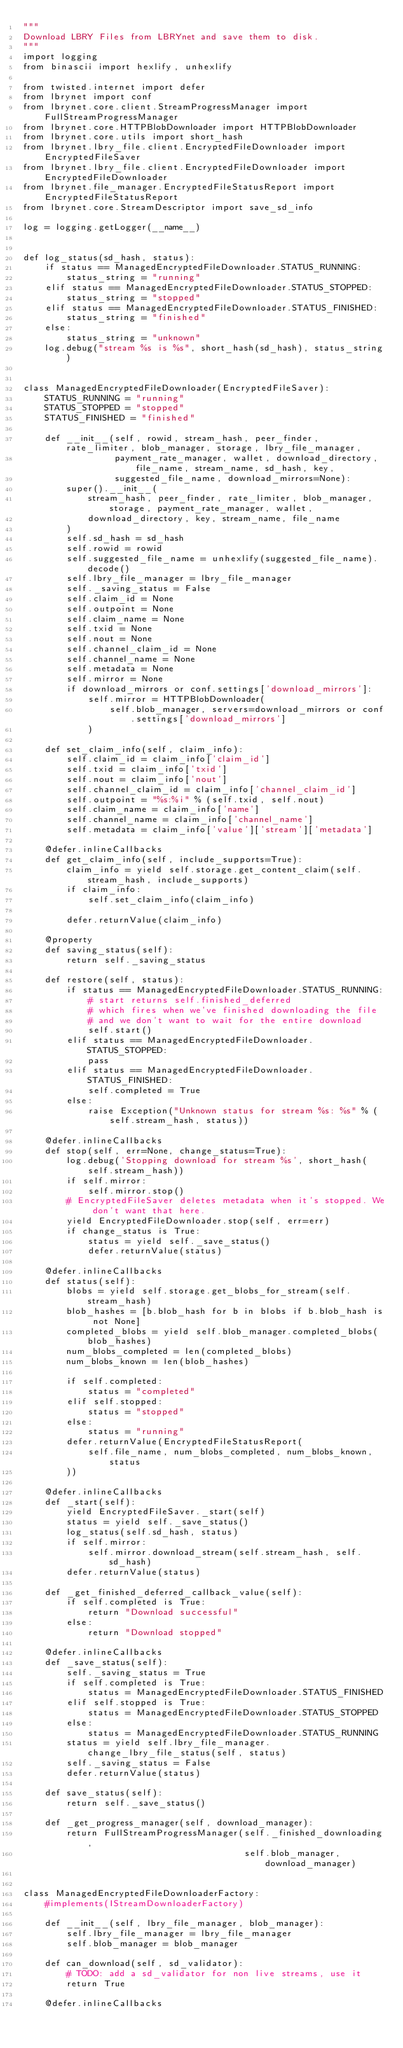Convert code to text. <code><loc_0><loc_0><loc_500><loc_500><_Python_>"""
Download LBRY Files from LBRYnet and save them to disk.
"""
import logging
from binascii import hexlify, unhexlify

from twisted.internet import defer
from lbrynet import conf
from lbrynet.core.client.StreamProgressManager import FullStreamProgressManager
from lbrynet.core.HTTPBlobDownloader import HTTPBlobDownloader
from lbrynet.core.utils import short_hash
from lbrynet.lbry_file.client.EncryptedFileDownloader import EncryptedFileSaver
from lbrynet.lbry_file.client.EncryptedFileDownloader import EncryptedFileDownloader
from lbrynet.file_manager.EncryptedFileStatusReport import EncryptedFileStatusReport
from lbrynet.core.StreamDescriptor import save_sd_info

log = logging.getLogger(__name__)


def log_status(sd_hash, status):
    if status == ManagedEncryptedFileDownloader.STATUS_RUNNING:
        status_string = "running"
    elif status == ManagedEncryptedFileDownloader.STATUS_STOPPED:
        status_string = "stopped"
    elif status == ManagedEncryptedFileDownloader.STATUS_FINISHED:
        status_string = "finished"
    else:
        status_string = "unknown"
    log.debug("stream %s is %s", short_hash(sd_hash), status_string)


class ManagedEncryptedFileDownloader(EncryptedFileSaver):
    STATUS_RUNNING = "running"
    STATUS_STOPPED = "stopped"
    STATUS_FINISHED = "finished"

    def __init__(self, rowid, stream_hash, peer_finder, rate_limiter, blob_manager, storage, lbry_file_manager,
                 payment_rate_manager, wallet, download_directory, file_name, stream_name, sd_hash, key,
                 suggested_file_name, download_mirrors=None):
        super().__init__(
            stream_hash, peer_finder, rate_limiter, blob_manager, storage, payment_rate_manager, wallet,
            download_directory, key, stream_name, file_name
        )
        self.sd_hash = sd_hash
        self.rowid = rowid
        self.suggested_file_name = unhexlify(suggested_file_name).decode()
        self.lbry_file_manager = lbry_file_manager
        self._saving_status = False
        self.claim_id = None
        self.outpoint = None
        self.claim_name = None
        self.txid = None
        self.nout = None
        self.channel_claim_id = None
        self.channel_name = None
        self.metadata = None
        self.mirror = None
        if download_mirrors or conf.settings['download_mirrors']:
            self.mirror = HTTPBlobDownloader(
                self.blob_manager, servers=download_mirrors or conf.settings['download_mirrors']
            )

    def set_claim_info(self, claim_info):
        self.claim_id = claim_info['claim_id']
        self.txid = claim_info['txid']
        self.nout = claim_info['nout']
        self.channel_claim_id = claim_info['channel_claim_id']
        self.outpoint = "%s:%i" % (self.txid, self.nout)
        self.claim_name = claim_info['name']
        self.channel_name = claim_info['channel_name']
        self.metadata = claim_info['value']['stream']['metadata']

    @defer.inlineCallbacks
    def get_claim_info(self, include_supports=True):
        claim_info = yield self.storage.get_content_claim(self.stream_hash, include_supports)
        if claim_info:
            self.set_claim_info(claim_info)

        defer.returnValue(claim_info)

    @property
    def saving_status(self):
        return self._saving_status

    def restore(self, status):
        if status == ManagedEncryptedFileDownloader.STATUS_RUNNING:
            # start returns self.finished_deferred
            # which fires when we've finished downloading the file
            # and we don't want to wait for the entire download
            self.start()
        elif status == ManagedEncryptedFileDownloader.STATUS_STOPPED:
            pass
        elif status == ManagedEncryptedFileDownloader.STATUS_FINISHED:
            self.completed = True
        else:
            raise Exception("Unknown status for stream %s: %s" % (self.stream_hash, status))

    @defer.inlineCallbacks
    def stop(self, err=None, change_status=True):
        log.debug('Stopping download for stream %s', short_hash(self.stream_hash))
        if self.mirror:
            self.mirror.stop()
        # EncryptedFileSaver deletes metadata when it's stopped. We don't want that here.
        yield EncryptedFileDownloader.stop(self, err=err)
        if change_status is True:
            status = yield self._save_status()
            defer.returnValue(status)

    @defer.inlineCallbacks
    def status(self):
        blobs = yield self.storage.get_blobs_for_stream(self.stream_hash)
        blob_hashes = [b.blob_hash for b in blobs if b.blob_hash is not None]
        completed_blobs = yield self.blob_manager.completed_blobs(blob_hashes)
        num_blobs_completed = len(completed_blobs)
        num_blobs_known = len(blob_hashes)

        if self.completed:
            status = "completed"
        elif self.stopped:
            status = "stopped"
        else:
            status = "running"
        defer.returnValue(EncryptedFileStatusReport(
            self.file_name, num_blobs_completed, num_blobs_known, status
        ))

    @defer.inlineCallbacks
    def _start(self):
        yield EncryptedFileSaver._start(self)
        status = yield self._save_status()
        log_status(self.sd_hash, status)
        if self.mirror:
            self.mirror.download_stream(self.stream_hash, self.sd_hash)
        defer.returnValue(status)

    def _get_finished_deferred_callback_value(self):
        if self.completed is True:
            return "Download successful"
        else:
            return "Download stopped"

    @defer.inlineCallbacks
    def _save_status(self):
        self._saving_status = True
        if self.completed is True:
            status = ManagedEncryptedFileDownloader.STATUS_FINISHED
        elif self.stopped is True:
            status = ManagedEncryptedFileDownloader.STATUS_STOPPED
        else:
            status = ManagedEncryptedFileDownloader.STATUS_RUNNING
        status = yield self.lbry_file_manager.change_lbry_file_status(self, status)
        self._saving_status = False
        defer.returnValue(status)

    def save_status(self):
        return self._save_status()

    def _get_progress_manager(self, download_manager):
        return FullStreamProgressManager(self._finished_downloading,
                                         self.blob_manager, download_manager)


class ManagedEncryptedFileDownloaderFactory:
    #implements(IStreamDownloaderFactory)

    def __init__(self, lbry_file_manager, blob_manager):
        self.lbry_file_manager = lbry_file_manager
        self.blob_manager = blob_manager

    def can_download(self, sd_validator):
        # TODO: add a sd_validator for non live streams, use it
        return True

    @defer.inlineCallbacks</code> 